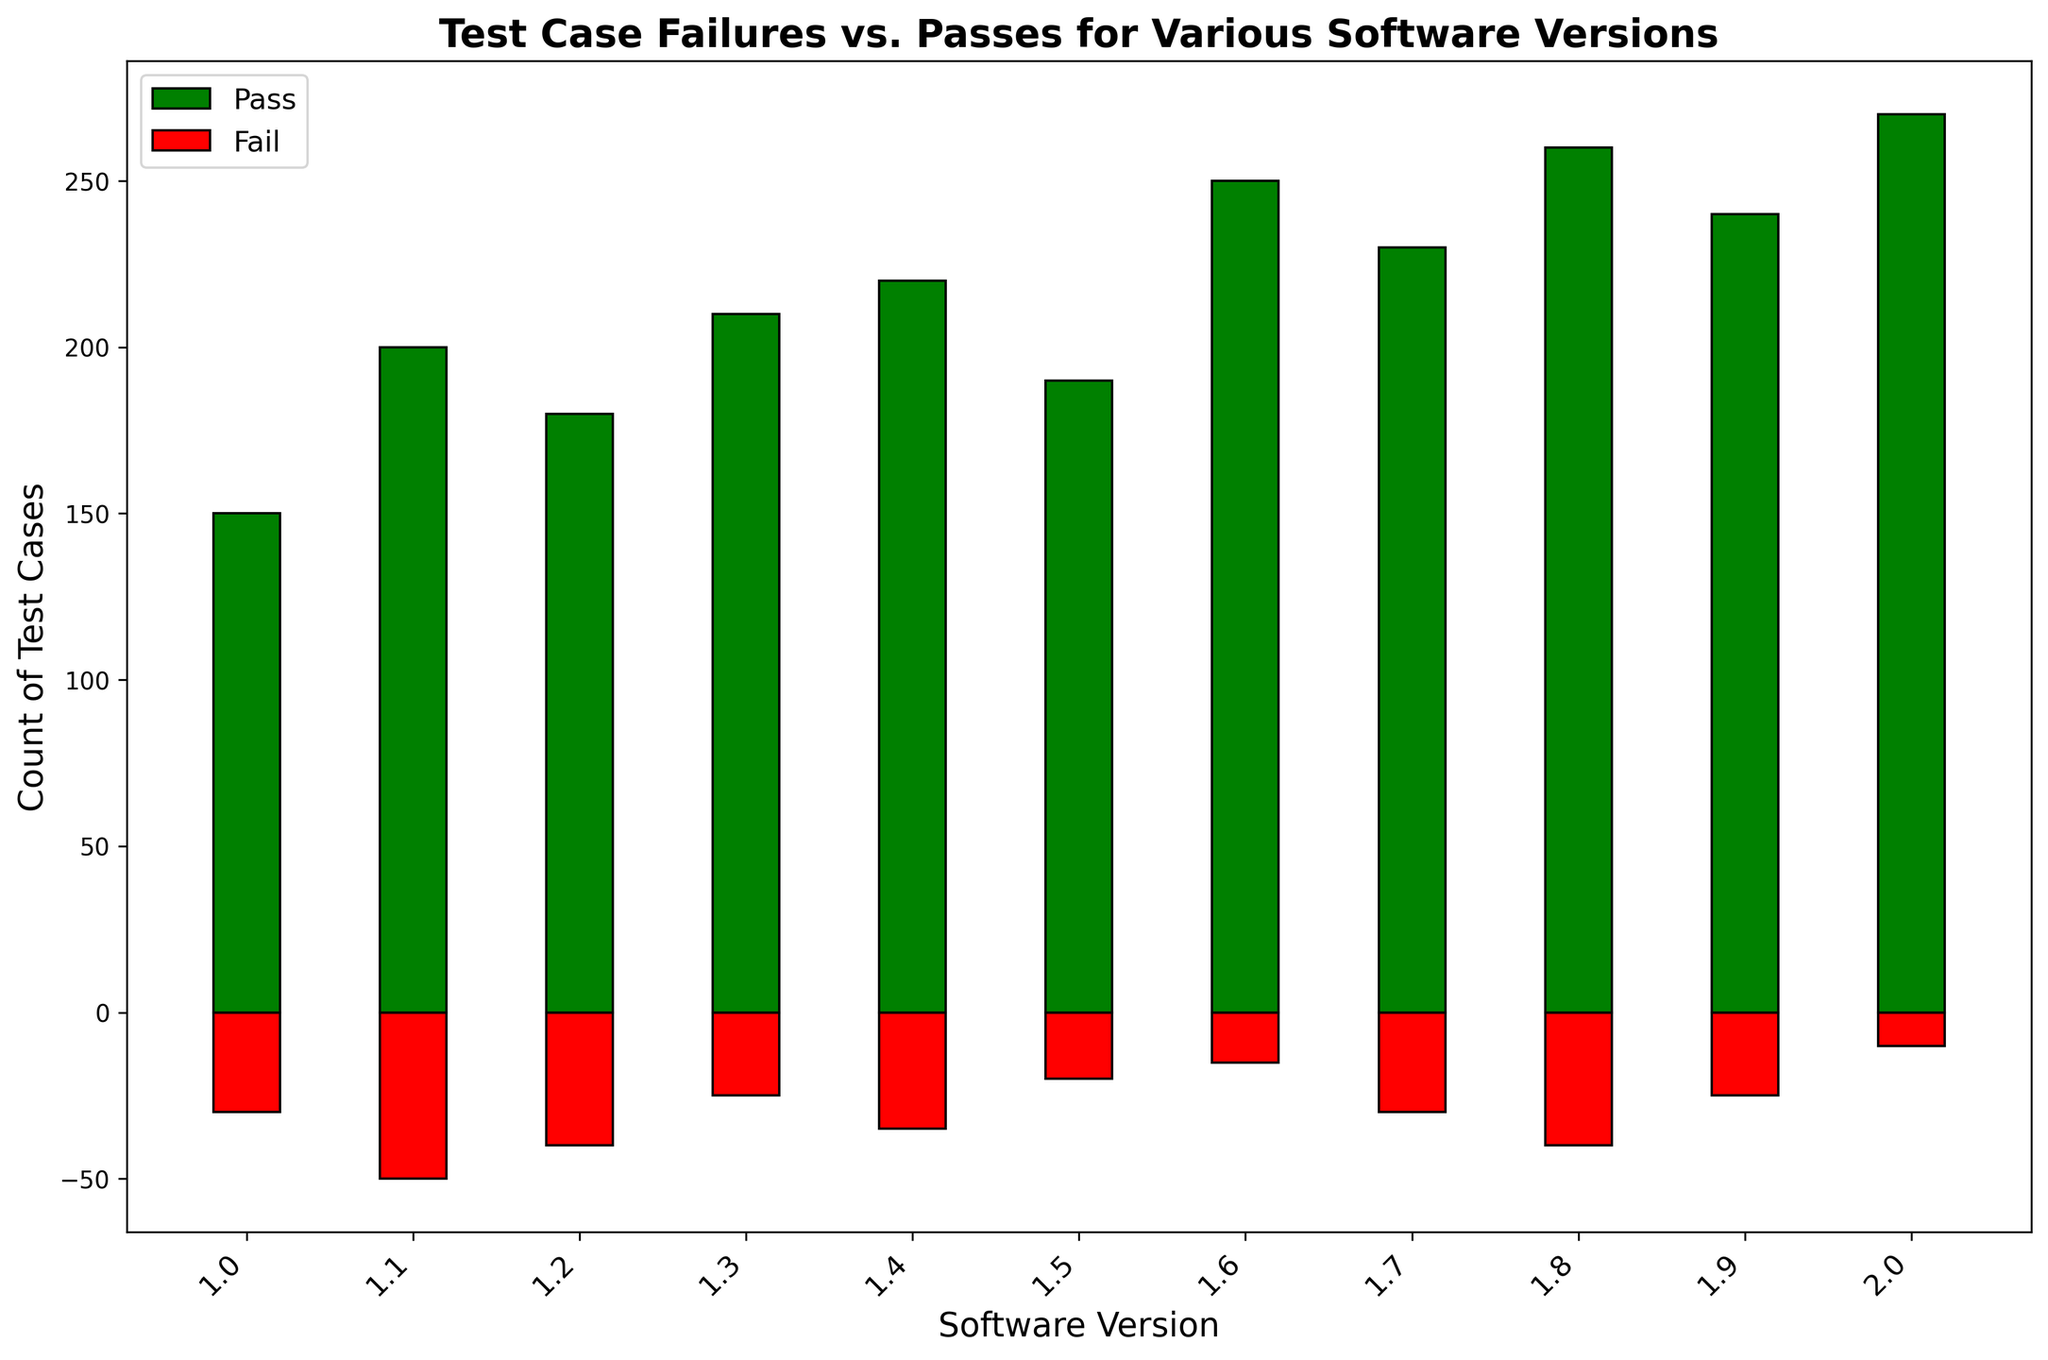How many test cases passed in versions 1.4 and 2.0 combined? First, identify the pass counts for versions 1.4 and 2.0 from the bar chart: 220 (for 1.4) and 270 (for 2.0). Then, sum these values: 220 + 270 = 490.
Answer: 490 Which version has the most test case failures? Look for the version with the tallest red bar (indicating failures). Version 1.1 has the highest count of failures at -50.
Answer: 1.1 By how much do the passes in version 2.0 exceed the passes in version 1.0? Identify the pass counts: 270 (for 2.0) and 150 (for 1.0). Find the difference: 270 - 150 = 120.
Answer: 120 What is the total number of test case failures across all versions? Add the negative values of failures from all versions: -30 + -50 + -40 + -25 + -35 + -20 + -15 + -30 + -40 + -25 + -10 = -320.
Answer: 320 Which version has an equal number of test case passes and the most number of test case failures? The pass count for version 1.1 is 200, and it also has the highest failure count at -50.
Answer: 1.1 How many more test cases passed in version 1.8 compared to version 1.2? Identify the pass counts: 260 (for 1.8) and 180 (for 1.2). Find the difference: 260 - 180 = 80.
Answer: 80 What is the difference between the maximum and minimum pass counts? The maximum pass count is 270 (version 2.0), and the minimum is 150 (version 1.0). Calculate the difference: 270 - 150 = 120.
Answer: 120 Which software version has the lowest number of test case failures? Identify the shortest red bar (indicating failures) on the chart. Version 2.0 has the lowest number of failures at -10.
Answer: 2.0 